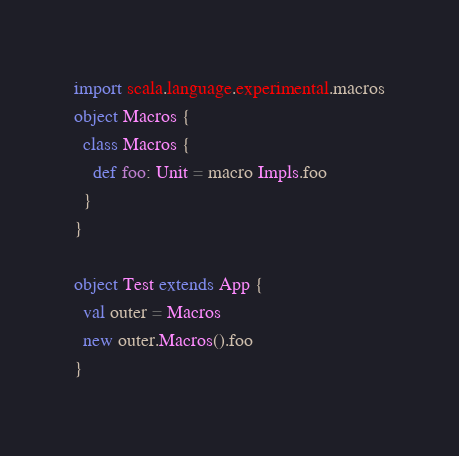Convert code to text. <code><loc_0><loc_0><loc_500><loc_500><_Scala_>import scala.language.experimental.macros
object Macros {
  class Macros {
    def foo: Unit = macro Impls.foo
  }
}

object Test extends App {
  val outer = Macros
  new outer.Macros().foo
}
</code> 